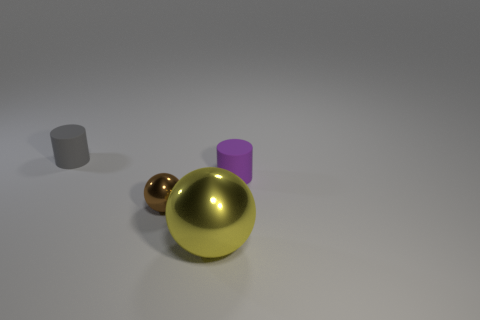What shape is the gray matte object that is the same size as the brown object?
Offer a very short reply. Cylinder. How many other objects are the same color as the tiny sphere?
Make the answer very short. 0. What material is the small gray thing?
Provide a succinct answer. Rubber. What number of other objects are the same material as the small gray thing?
Make the answer very short. 1. There is a object that is on the left side of the yellow thing and to the right of the small gray thing; what size is it?
Keep it short and to the point. Small. What is the shape of the tiny rubber thing to the right of the metal thing that is left of the big object?
Provide a short and direct response. Cylinder. Is there any other thing that is the same shape as the small brown thing?
Ensure brevity in your answer.  Yes. Are there an equal number of objects to the left of the gray thing and tiny purple matte cylinders?
Keep it short and to the point. No. Does the small sphere have the same color as the matte cylinder in front of the gray object?
Ensure brevity in your answer.  No. There is a object that is both behind the big yellow metallic sphere and in front of the small purple thing; what color is it?
Keep it short and to the point. Brown. 